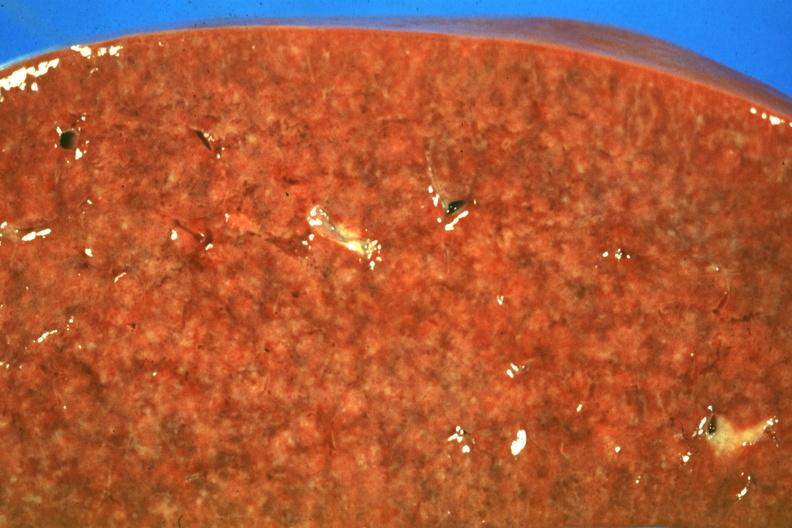s natural color present?
Answer the question using a single word or phrase. No 